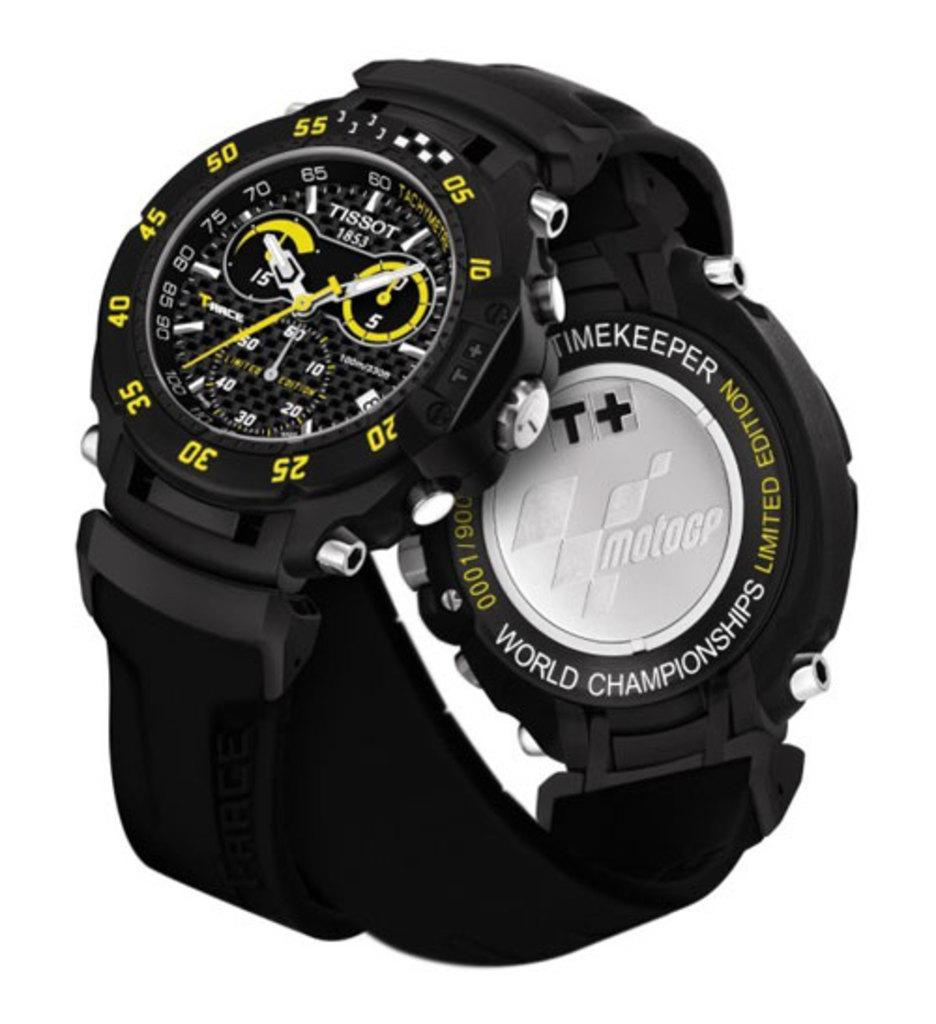<image>
Give a short and clear explanation of the subsequent image. A Tissot brand watch wrapped around a watch that says Moto GP on the face. 